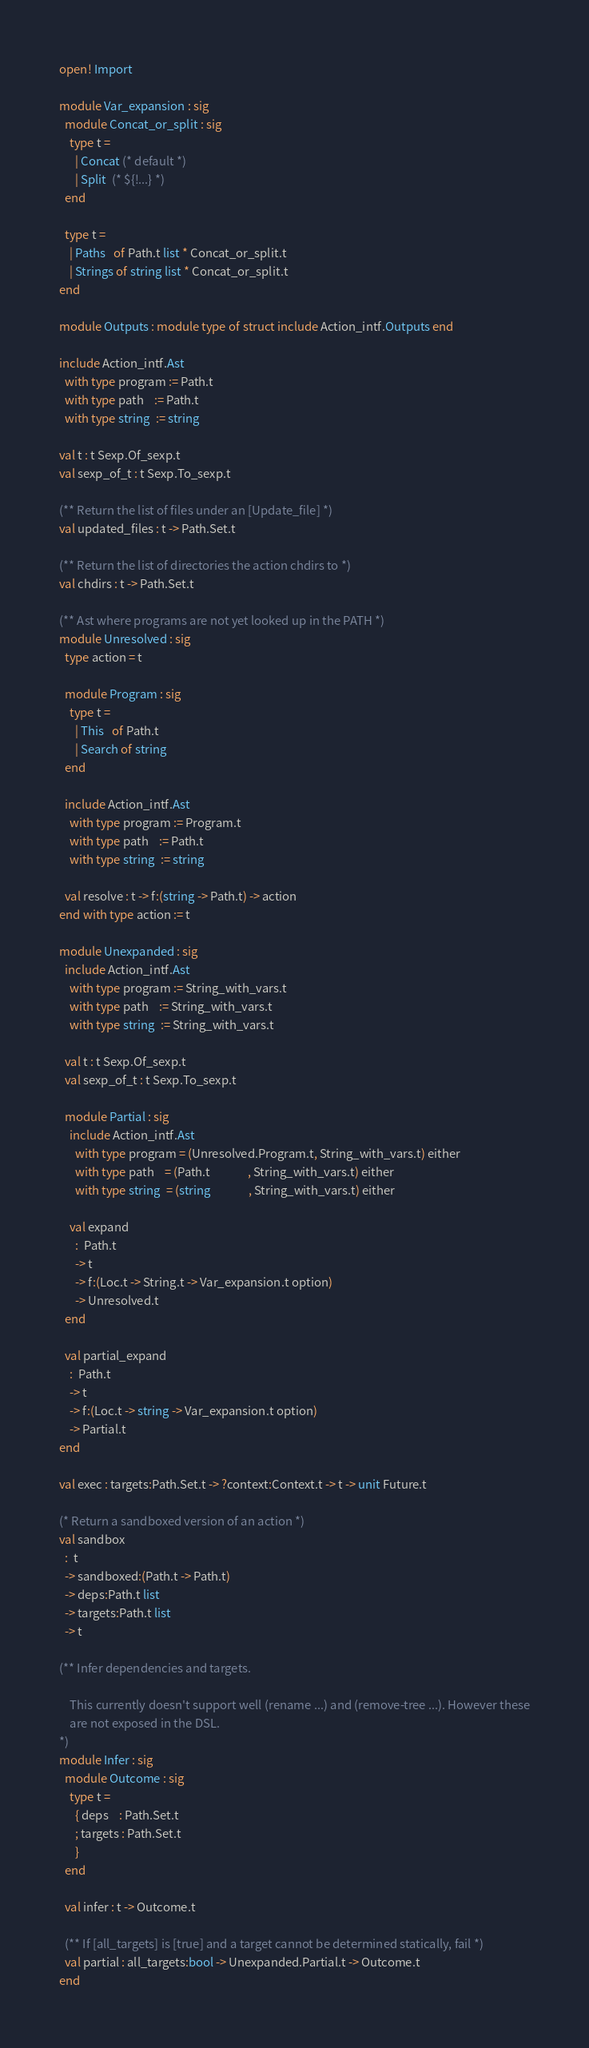<code> <loc_0><loc_0><loc_500><loc_500><_OCaml_>open! Import

module Var_expansion : sig
  module Concat_or_split : sig
    type t =
      | Concat (* default *)
      | Split  (* ${!...} *)
  end

  type t =
    | Paths   of Path.t list * Concat_or_split.t
    | Strings of string list * Concat_or_split.t
end

module Outputs : module type of struct include Action_intf.Outputs end

include Action_intf.Ast
  with type program := Path.t
  with type path    := Path.t
  with type string  := string

val t : t Sexp.Of_sexp.t
val sexp_of_t : t Sexp.To_sexp.t

(** Return the list of files under an [Update_file] *)
val updated_files : t -> Path.Set.t

(** Return the list of directories the action chdirs to *)
val chdirs : t -> Path.Set.t

(** Ast where programs are not yet looked up in the PATH *)
module Unresolved : sig
  type action = t

  module Program : sig
    type t =
      | This   of Path.t
      | Search of string
  end

  include Action_intf.Ast
    with type program := Program.t
    with type path    := Path.t
    with type string  := string

  val resolve : t -> f:(string -> Path.t) -> action
end with type action := t

module Unexpanded : sig
  include Action_intf.Ast
    with type program := String_with_vars.t
    with type path    := String_with_vars.t
    with type string  := String_with_vars.t

  val t : t Sexp.Of_sexp.t
  val sexp_of_t : t Sexp.To_sexp.t

  module Partial : sig
    include Action_intf.Ast
      with type program = (Unresolved.Program.t, String_with_vars.t) either
      with type path    = (Path.t              , String_with_vars.t) either
      with type string  = (string              , String_with_vars.t) either

    val expand
      :  Path.t
      -> t
      -> f:(Loc.t -> String.t -> Var_expansion.t option)
      -> Unresolved.t
  end

  val partial_expand
    :  Path.t
    -> t
    -> f:(Loc.t -> string -> Var_expansion.t option)
    -> Partial.t
end

val exec : targets:Path.Set.t -> ?context:Context.t -> t -> unit Future.t

(* Return a sandboxed version of an action *)
val sandbox
  :  t
  -> sandboxed:(Path.t -> Path.t)
  -> deps:Path.t list
  -> targets:Path.t list
  -> t

(** Infer dependencies and targets.

    This currently doesn't support well (rename ...) and (remove-tree ...). However these
    are not exposed in the DSL.
*)
module Infer : sig
  module Outcome : sig
    type t =
      { deps    : Path.Set.t
      ; targets : Path.Set.t
      }
  end

  val infer : t -> Outcome.t

  (** If [all_targets] is [true] and a target cannot be determined statically, fail *)
  val partial : all_targets:bool -> Unexpanded.Partial.t -> Outcome.t
end
</code> 